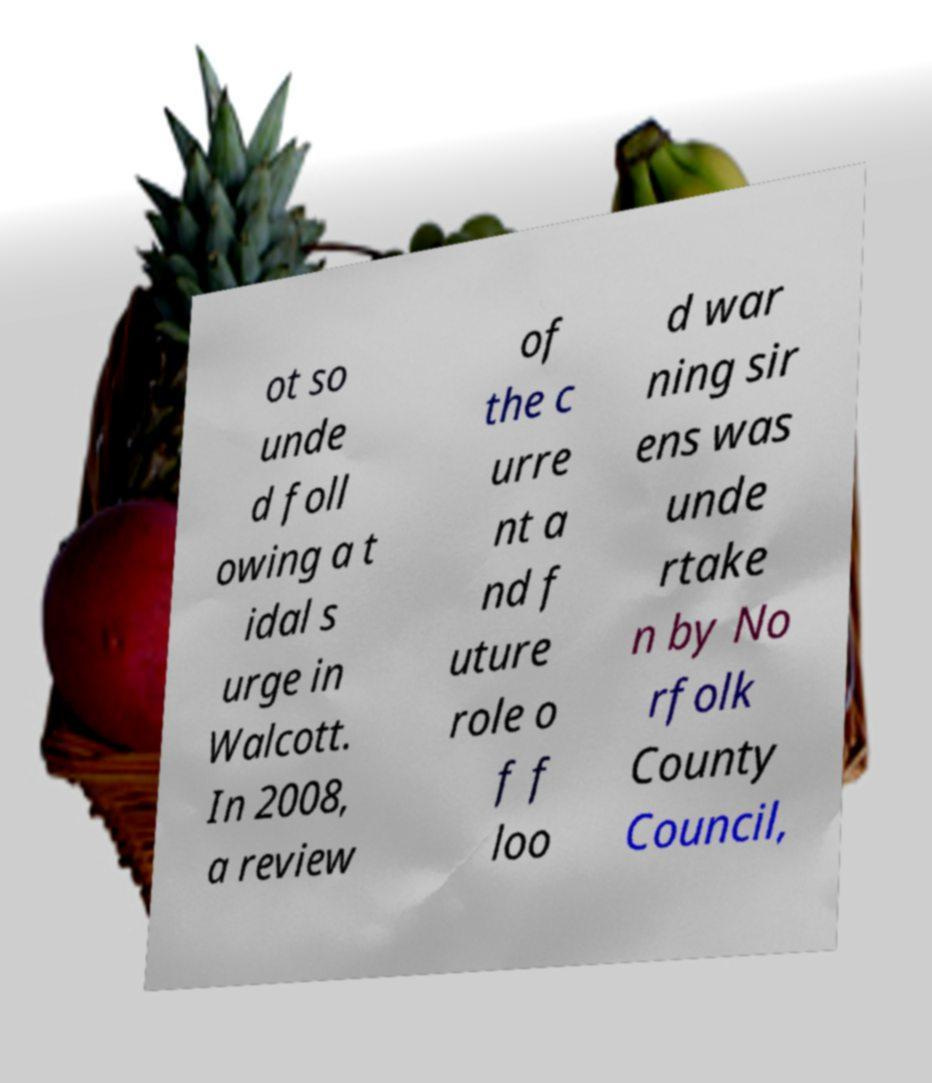What messages or text are displayed in this image? I need them in a readable, typed format. ot so unde d foll owing a t idal s urge in Walcott. In 2008, a review of the c urre nt a nd f uture role o f f loo d war ning sir ens was unde rtake n by No rfolk County Council, 